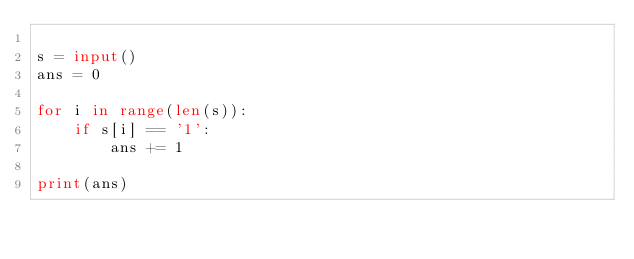Convert code to text. <code><loc_0><loc_0><loc_500><loc_500><_Python_>
s = input()
ans = 0

for i in range(len(s)):
    if s[i] == '1':
        ans += 1

print(ans)</code> 